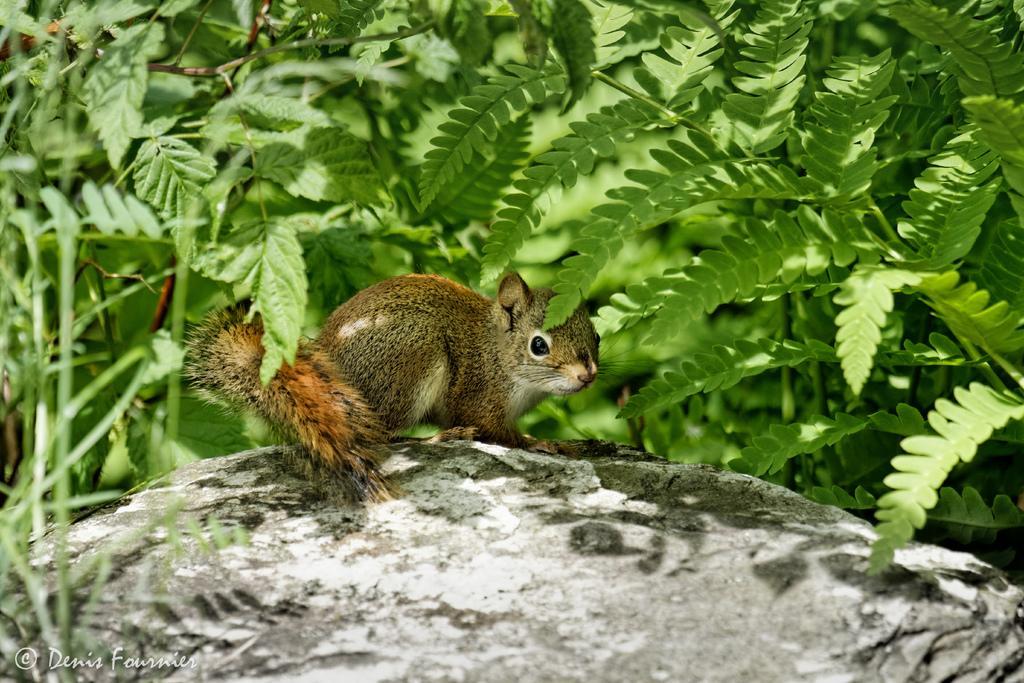How would you summarize this image in a sentence or two? In this image we can see a squirrel on the stone. In the background there are leaves of different plants. 